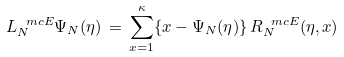Convert formula to latex. <formula><loc_0><loc_0><loc_500><loc_500>L ^ { \ m c E } _ { N } \Psi _ { N } ( \eta ) \, = \, \sum _ { x = 1 } ^ { \kappa } \{ x - \Psi _ { N } ( \eta ) \} \, R ^ { \ m c E } _ { N } ( \eta , x )</formula> 